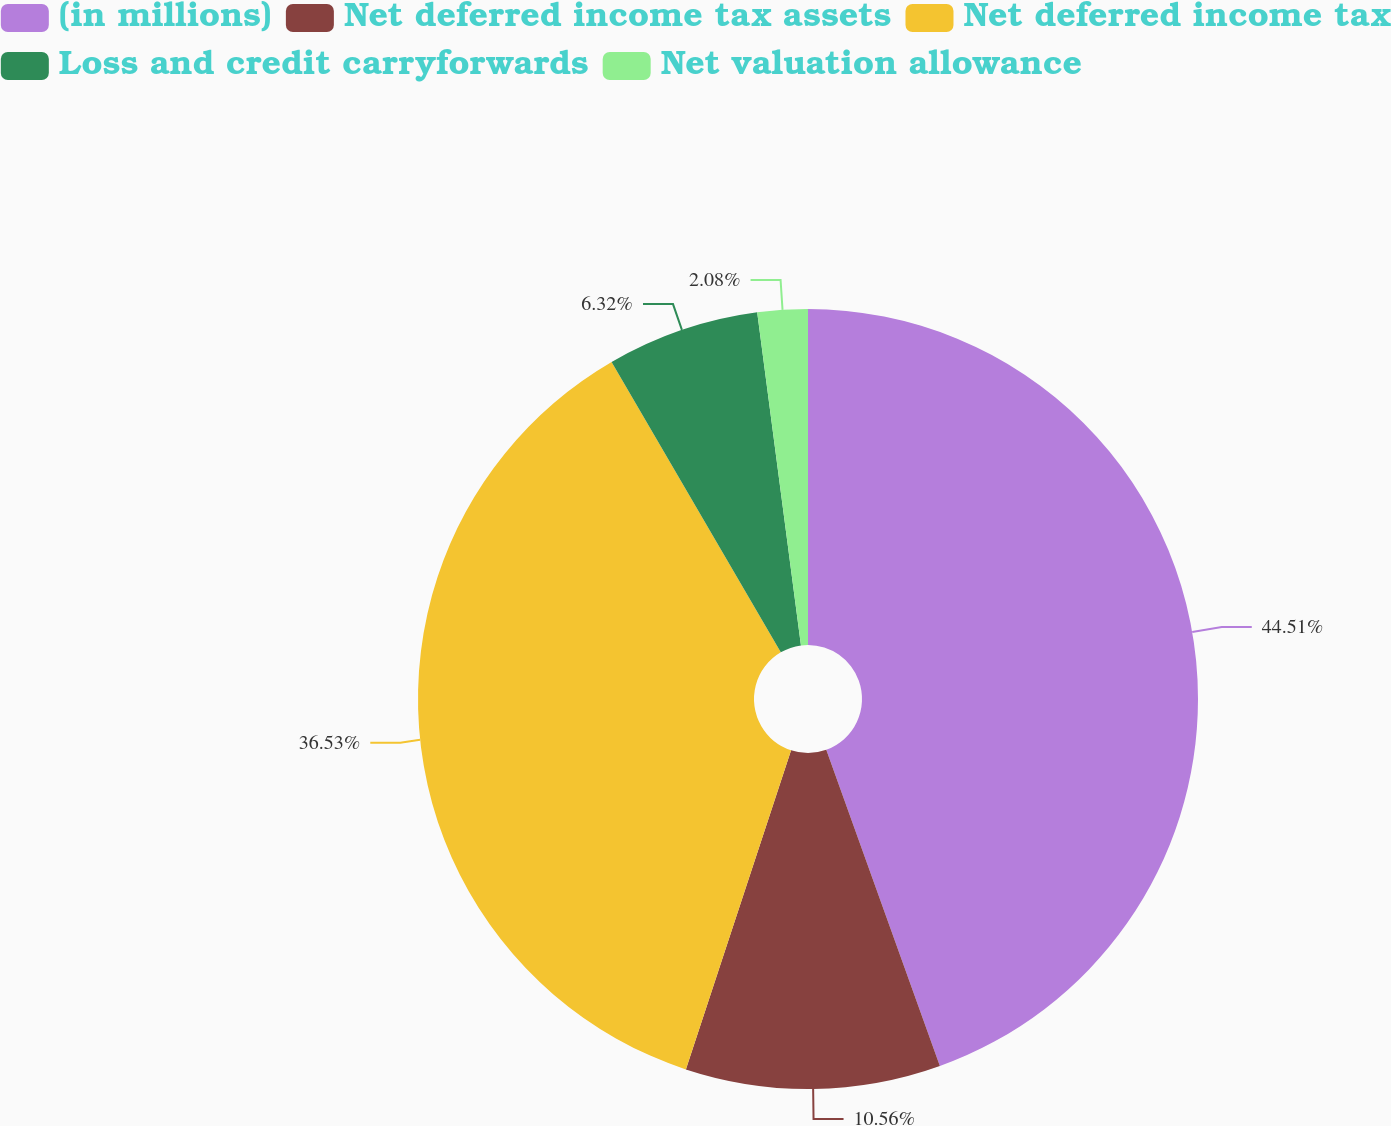Convert chart to OTSL. <chart><loc_0><loc_0><loc_500><loc_500><pie_chart><fcel>(in millions)<fcel>Net deferred income tax assets<fcel>Net deferred income tax<fcel>Loss and credit carryforwards<fcel>Net valuation allowance<nl><fcel>44.51%<fcel>10.56%<fcel>36.53%<fcel>6.32%<fcel>2.08%<nl></chart> 